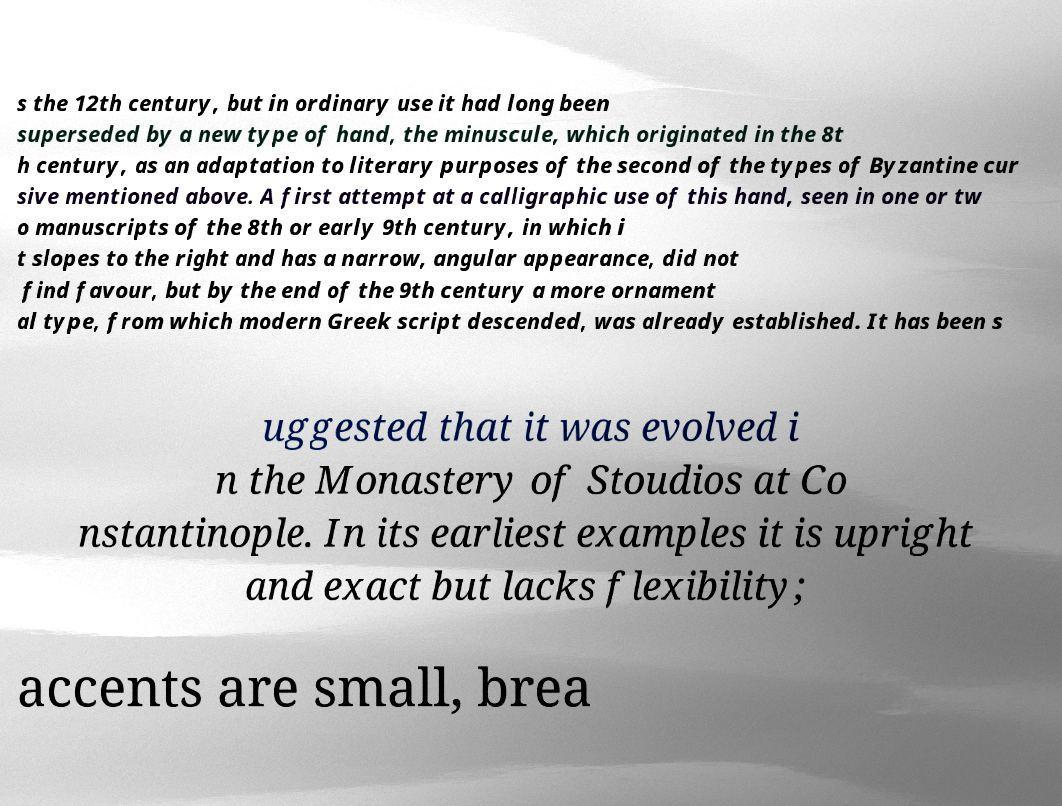Please identify and transcribe the text found in this image. s the 12th century, but in ordinary use it had long been superseded by a new type of hand, the minuscule, which originated in the 8t h century, as an adaptation to literary purposes of the second of the types of Byzantine cur sive mentioned above. A first attempt at a calligraphic use of this hand, seen in one or tw o manuscripts of the 8th or early 9th century, in which i t slopes to the right and has a narrow, angular appearance, did not find favour, but by the end of the 9th century a more ornament al type, from which modern Greek script descended, was already established. It has been s uggested that it was evolved i n the Monastery of Stoudios at Co nstantinople. In its earliest examples it is upright and exact but lacks flexibility; accents are small, brea 